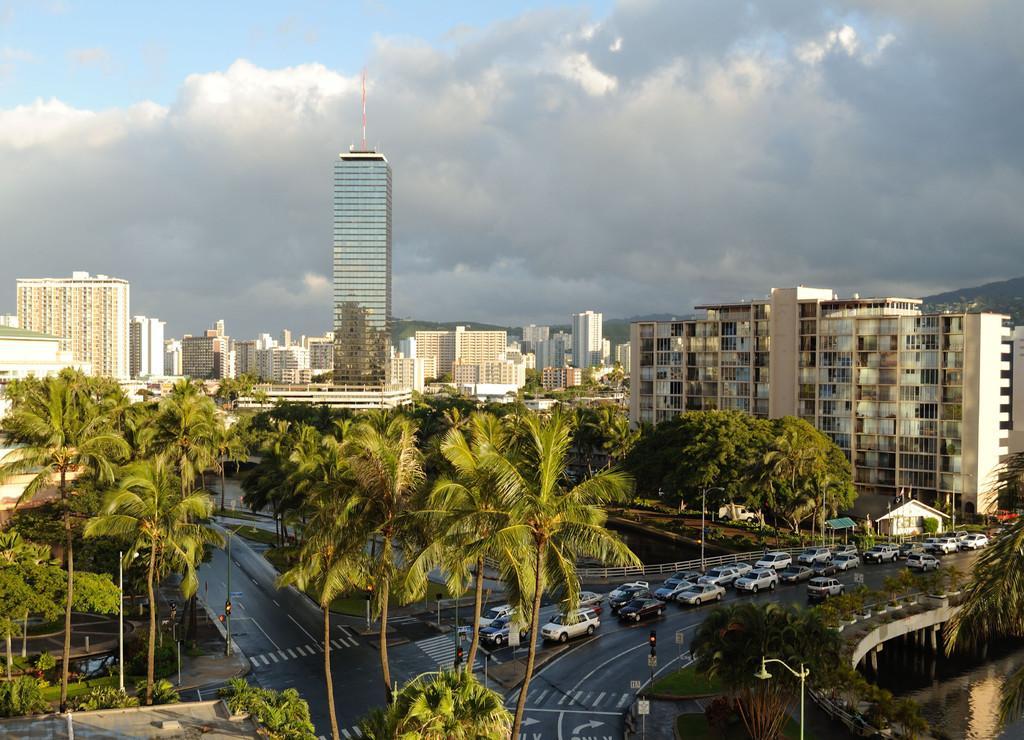How would you summarize this image in a sentence or two? This image is a aerial view. In this image we can see trees, road, traffic signals, vehicles, water, bridge, tower, hill, sky and clouds. 